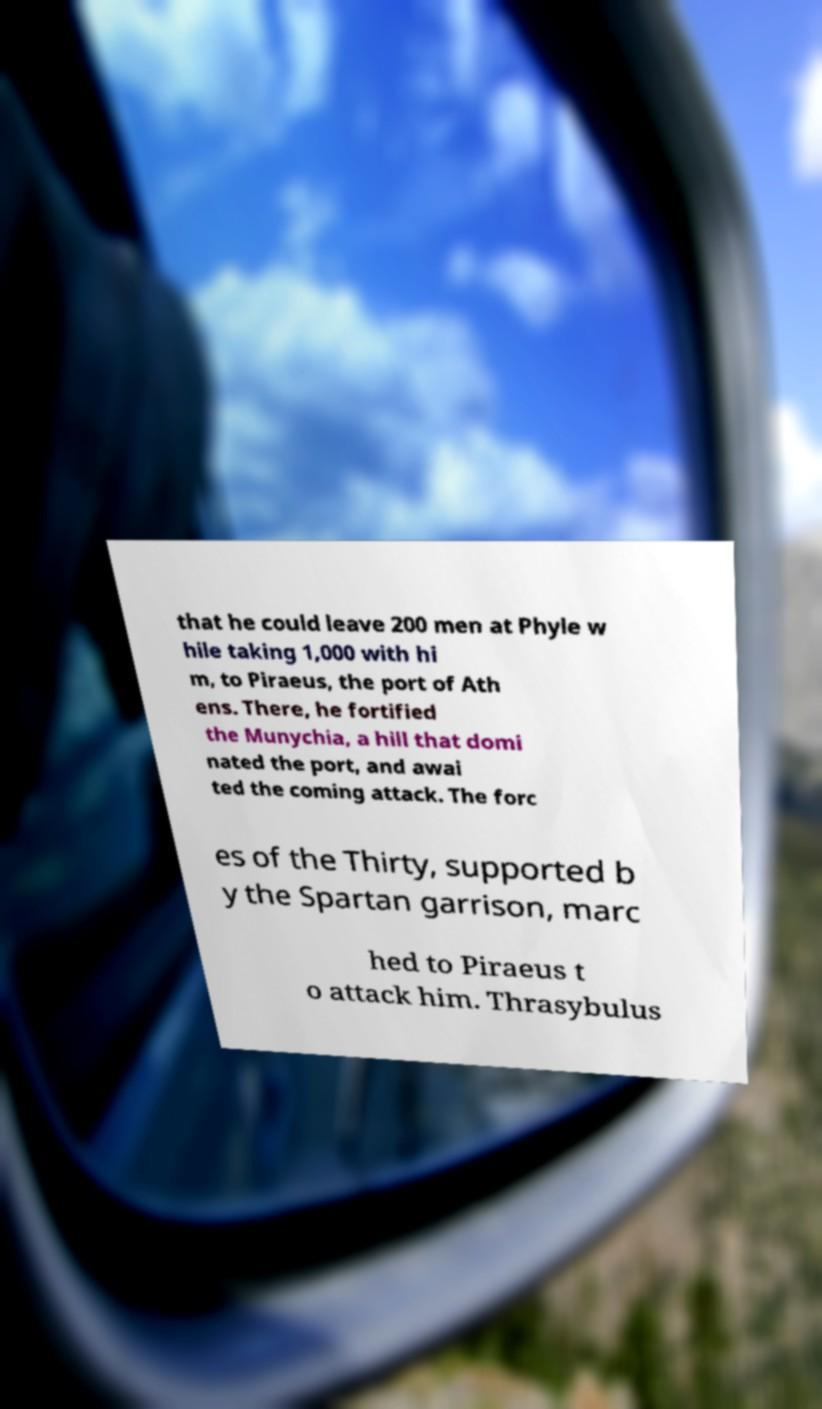Please identify and transcribe the text found in this image. that he could leave 200 men at Phyle w hile taking 1,000 with hi m, to Piraeus, the port of Ath ens. There, he fortified the Munychia, a hill that domi nated the port, and awai ted the coming attack. The forc es of the Thirty, supported b y the Spartan garrison, marc hed to Piraeus t o attack him. Thrasybulus 